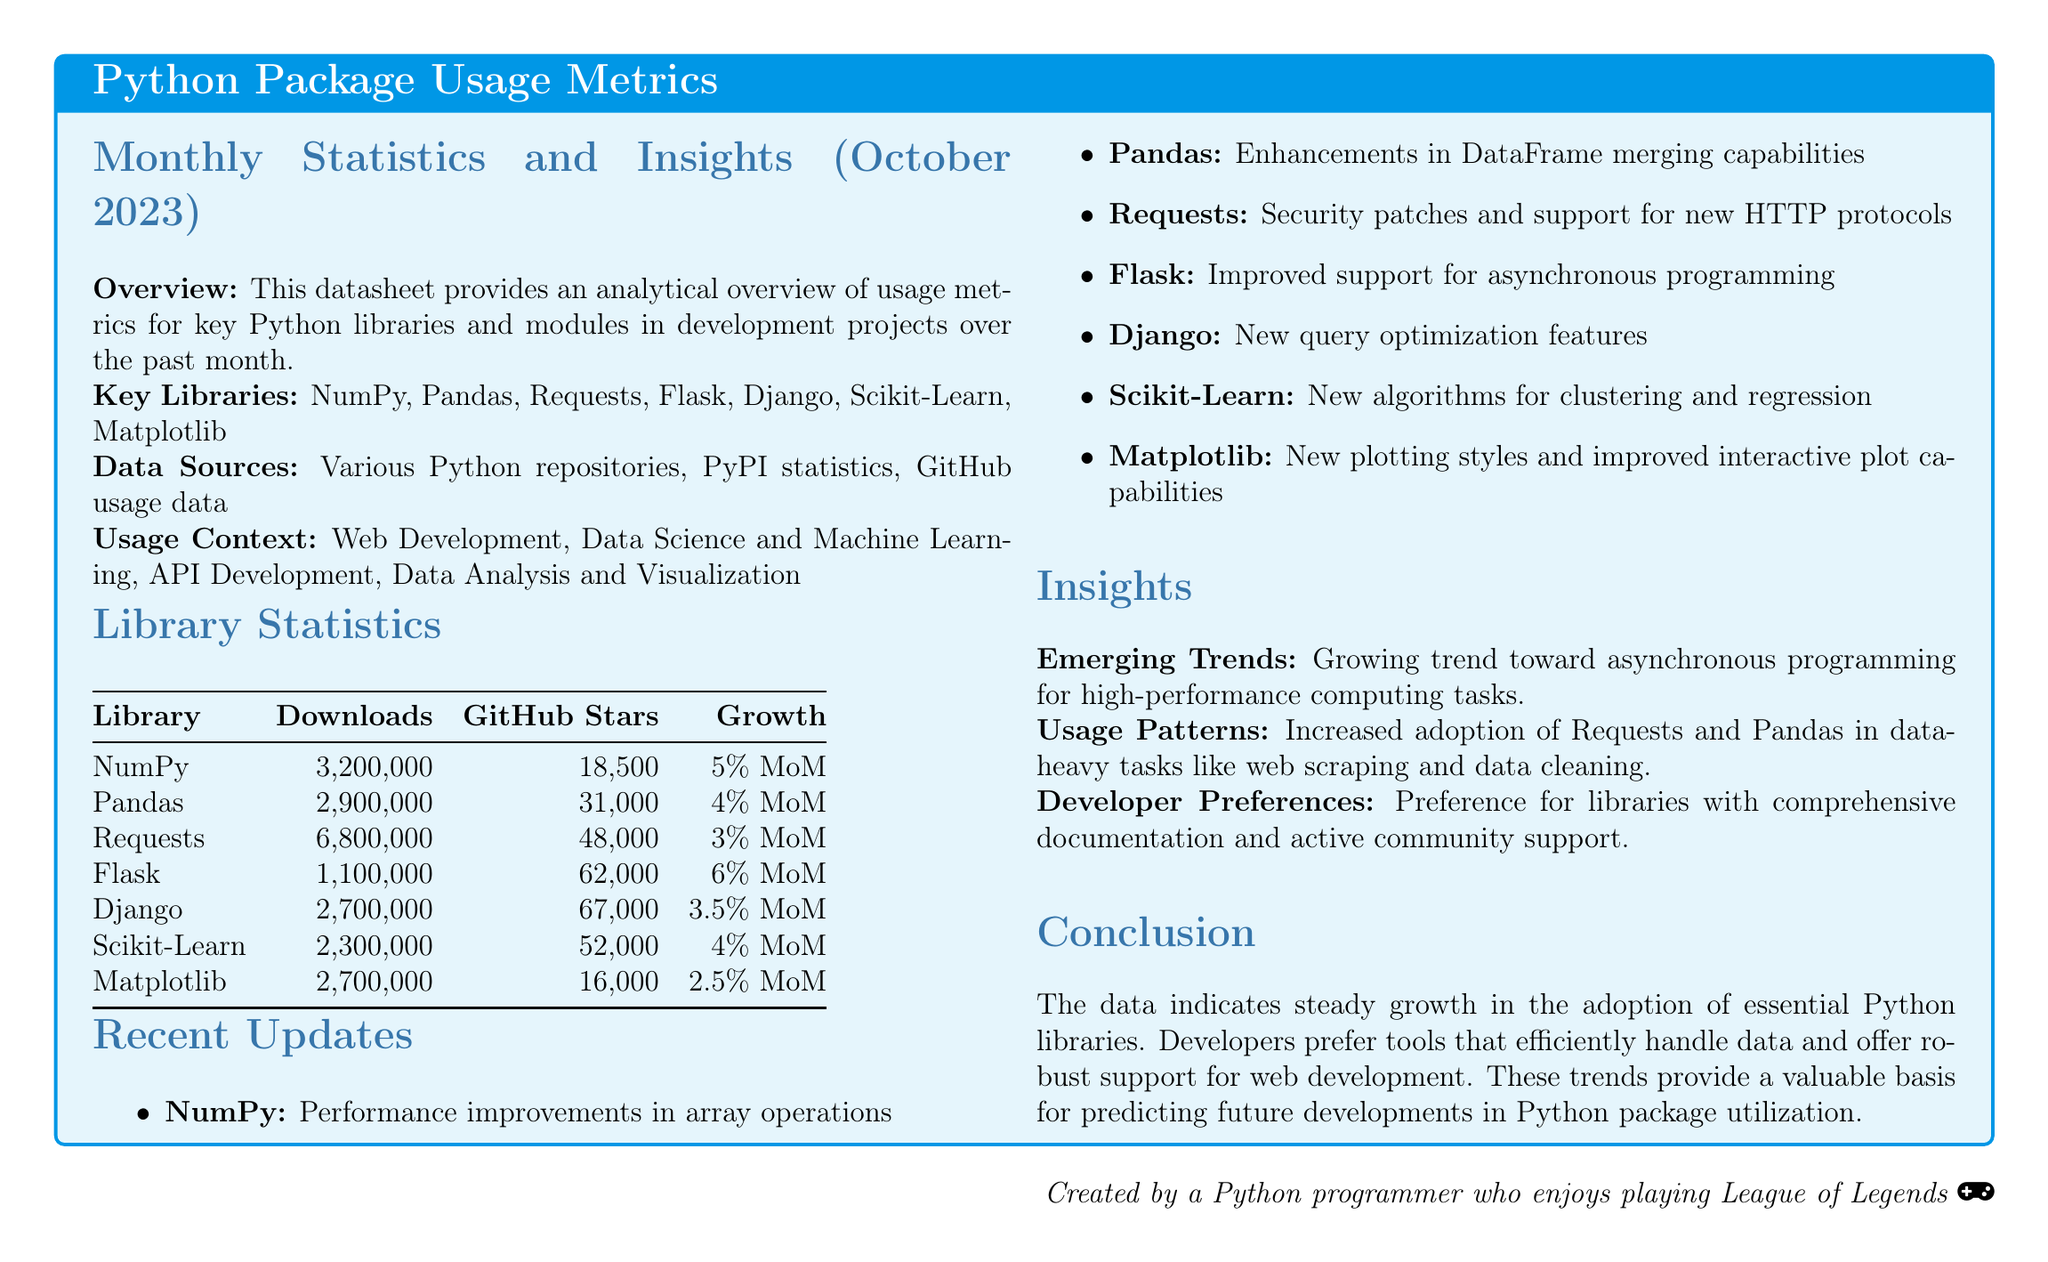What library had the highest downloads? The highest downloads can be found in the Library Statistics table, where Requests is shown to have 6,800,000 downloads.
Answer: Requests How many GitHub stars does Flask have? The number of GitHub stars for Flask is specified in the Library Statistics table, which shows 62,000 stars.
Answer: 62,000 What is the growth rate of NumPy? The growth rate for NumPy is explicitly stated in the Library Statistics table as 5% MoM.
Answer: 5% MoM Which library showed the highest growth rate? To determine the highest growth rate, one must compare the growth percentages in the Library Statistics; Flask is noted for having the highest at 6% MoM.
Answer: Flask What is a recent update for Scikit-Learn? The recent updates section lists new algorithms for clustering and regression as the update for Scikit-Learn.
Answer: New algorithms for clustering and regression What trend is emerging in the document? The emerging trends section highlights the growing trend toward asynchronous programming.
Answer: Asynchronous programming What is the primary focus of the usage context mentioned? The usage context outlines various focuses, including web development, specifically mentioning it as a significant area.
Answer: Web Development Which library has the most GitHub stars? The Library Statistics table indicates that Django has the most GitHub stars at 67,000.
Answer: Django What does the conclusion suggest about developer preferences? The conclusion mentions developers’ preferences for libraries with comprehensive documentation and active community support.
Answer: Comprehensive documentation and active community support 